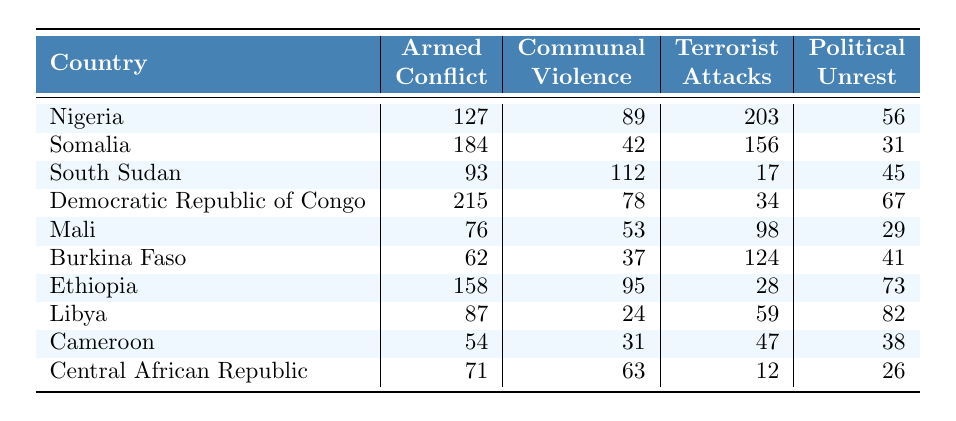What country has the highest number of terrorist attacks? Looking at the "Terrorist Attacks" column, Nigeria has the highest count with 203 attacks.
Answer: Nigeria Which country has the lowest level of armed conflict? In the "Armed Conflict" column, the country with the lowest number is Burkina Faso, which has 62 incidents.
Answer: Burkina Faso How many total incidents of communal violence were reported in Mali and Ethiopia combined? Adding the values for communal violence: Mali (53) + Ethiopia (95) = 148.
Answer: 148 Is the total number of armed conflict incidents in Somalia greater than the total number in Cameroon? The total for Somalia is 184, and for Cameroon, it is 54. Since 184 > 54, the statement is true.
Answer: Yes What is the average number of political unrest incidents across all countries listed? Summing the political unrest values: 56 + 31 + 45 + 67 + 29 + 41 + 73 + 82 + 38 + 26 = 448. There are 10 countries, so the average is 448 / 10 = 44.8.
Answer: 44.8 Which country has both high armed conflict and high communal violence incidents? Looking at the table, Somalia has 184 armed conflict incidents and 42 communal violence incidents, while Ethiopia has 158 and 95 respectively. Both numbers for Ethiopia are relatively high.
Answer: Ethiopia What is the difference in the number of terrorist attacks between Nigeria and Democratic Republic of Congo? Nigeria has 203 terrorist attacks and the Democratic Republic of Congo has 34. The difference is 203 - 34 = 169.
Answer: 169 How many countries have more than 80 incidents of political unrest? From the table, Algeria (56), Somalia (31), Democratic Republic of Congo (67), Libya (82) and South Sudan (45) all contribute. The countries with more than 80 incidents are Libya (82) and Ethiopia (73). Therefore, there are 4 countries.
Answer: 4 What is the total number of incidents across all types of violence for the Central African Republic? Adding all values for Central African Republic: 71 (armed conflict) + 63 (communal violence) + 12 (terrorist attacks) + 26 (political unrest) = 172.
Answer: 172 In which country is communal violence the highest when looking at only armed conflict and communal violence incidents? South Sudan has the highest communal violence count with 112 incidents, making it have a significant focus on that type of violence compared to the armed conflict incidents.
Answer: South Sudan 